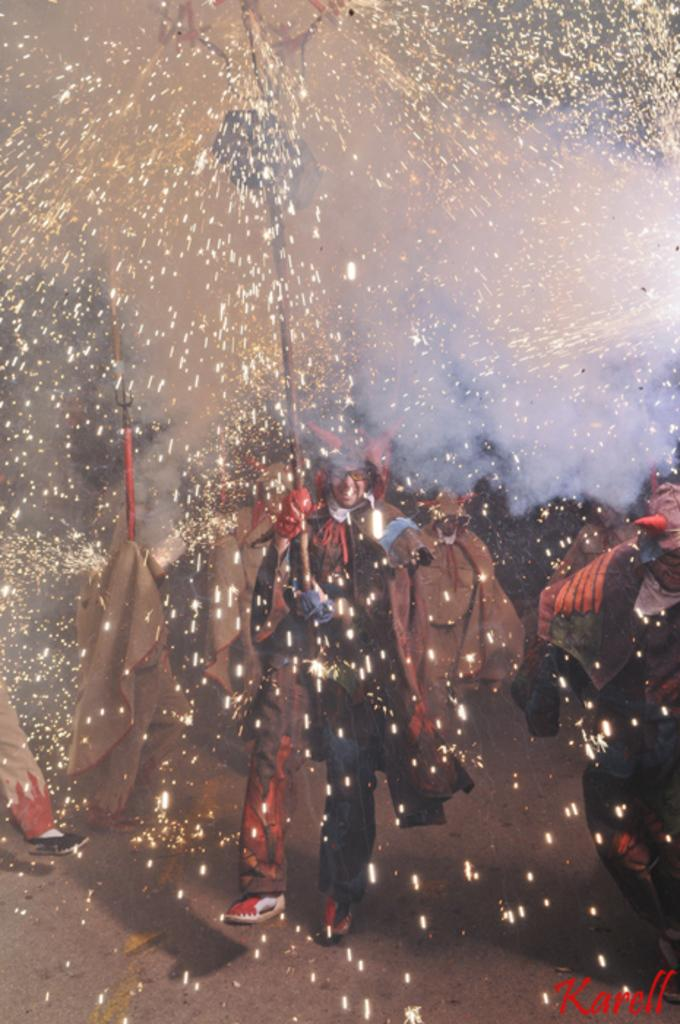Who or what is present in the image? There are people in the image. What can be seen in the image that is related to the people? There are sparks visible in the image. What type of substance is the pig rolling in on the grass in the image? There is no pig or grass present in the image; it only features people and sparks. 